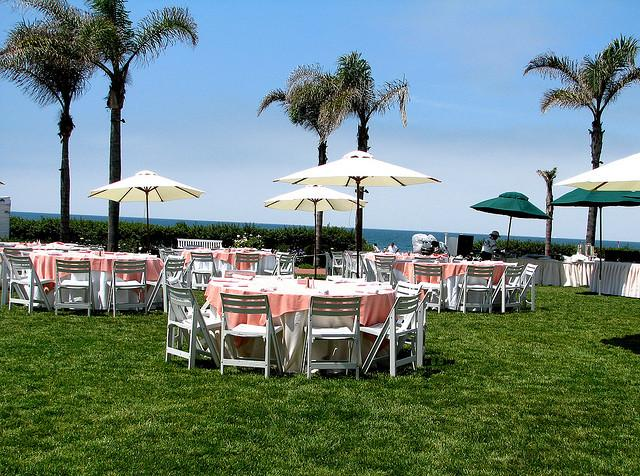What will be happening here in the very near future? wedding 